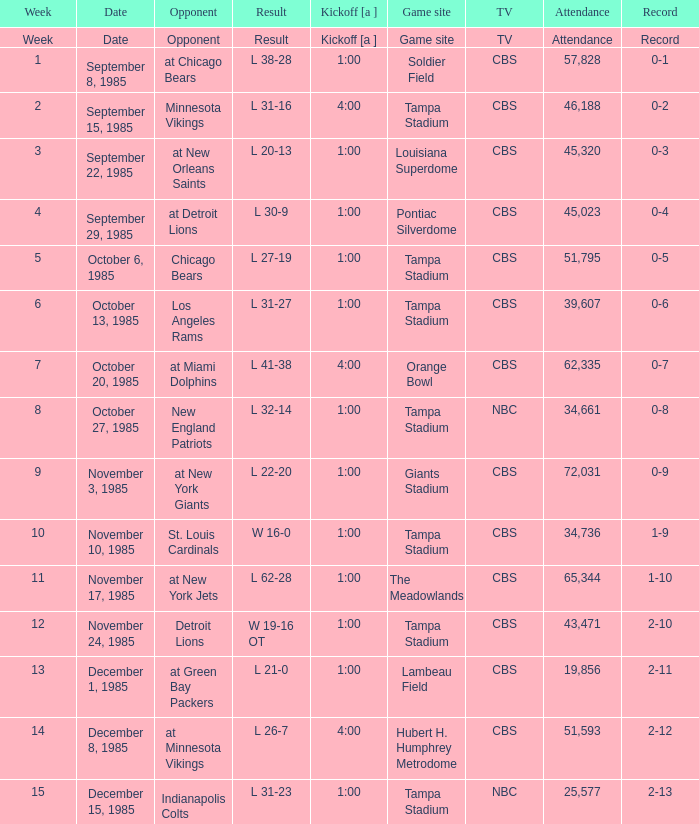Give me the kickoff time of the game that was aired on CBS against the St. Louis Cardinals.  1:00. 